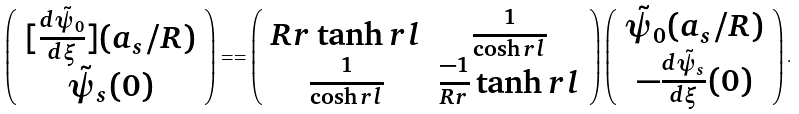<formula> <loc_0><loc_0><loc_500><loc_500>\left ( \begin{array} { c } [ \frac { d \tilde { \psi } _ { 0 } } { d \xi } ] ( a _ { s } / R ) \\ \tilde { \psi } _ { s } ( 0 ) \end{array} \right ) = = \left ( \begin{array} { c c } R r \tanh r l & \frac { 1 } { \cosh r l } \\ \frac { 1 } { \cosh r l } & \frac { - 1 } { R r } \tanh r l \end{array} \right ) \left ( \begin{array} { c } \tilde { \psi } _ { 0 } ( a _ { s } / R ) \\ - \frac { d \tilde { \psi } _ { s } } { d \xi } ( 0 ) \end{array} \right ) .</formula> 